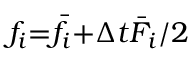Convert formula to latex. <formula><loc_0><loc_0><loc_500><loc_500>{ f _ { i } } { = } { { \bar { f } } _ { i } } { + } \Delta t { { \bar { F } } _ { i } } / 2</formula> 